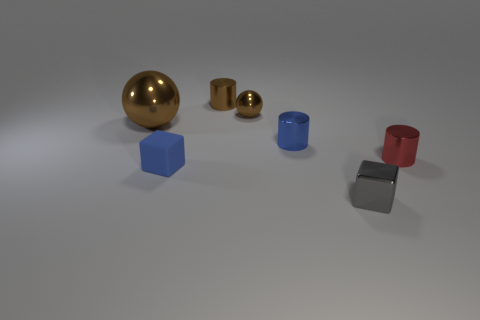Does the sphere that is on the right side of the blue matte object have the same material as the blue block?
Provide a short and direct response. No. Are there any brown shiny things that have the same size as the blue matte object?
Offer a very short reply. Yes. There is a large thing; is it the same shape as the brown thing to the right of the small brown shiny cylinder?
Offer a very short reply. Yes. There is a tiny cube that is right of the tiny metallic cylinder that is behind the big brown metal ball; is there a tiny blue block in front of it?
Provide a short and direct response. No. How many other objects are the same color as the tiny rubber cube?
Give a very brief answer. 1. Do the blue thing left of the tiny blue cylinder and the gray thing have the same shape?
Make the answer very short. Yes. There is another metallic thing that is the same shape as the big thing; what is its color?
Provide a succinct answer. Brown. Is there anything else that is made of the same material as the blue block?
Provide a succinct answer. No. There is a object that is left of the small brown cylinder and on the right side of the big thing; what material is it?
Your response must be concise. Rubber. Does the tiny cylinder right of the small gray metal block have the same color as the matte cube?
Provide a succinct answer. No. 